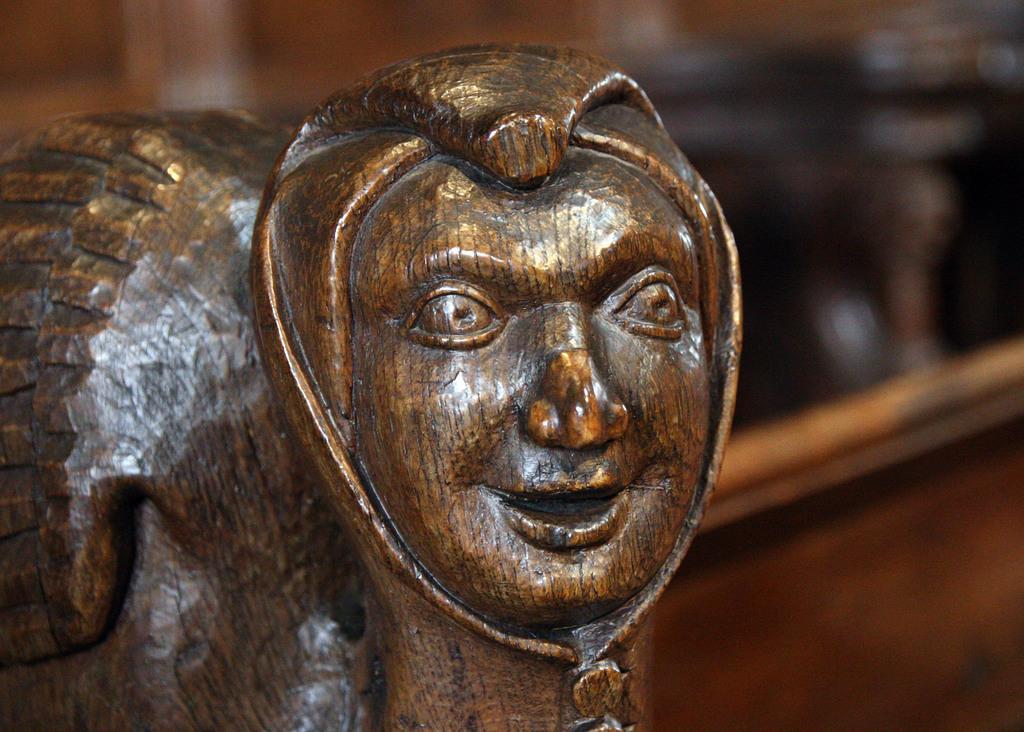Describe this image in one or two sentences. Here we can see a sculpture and there is a blur background. 